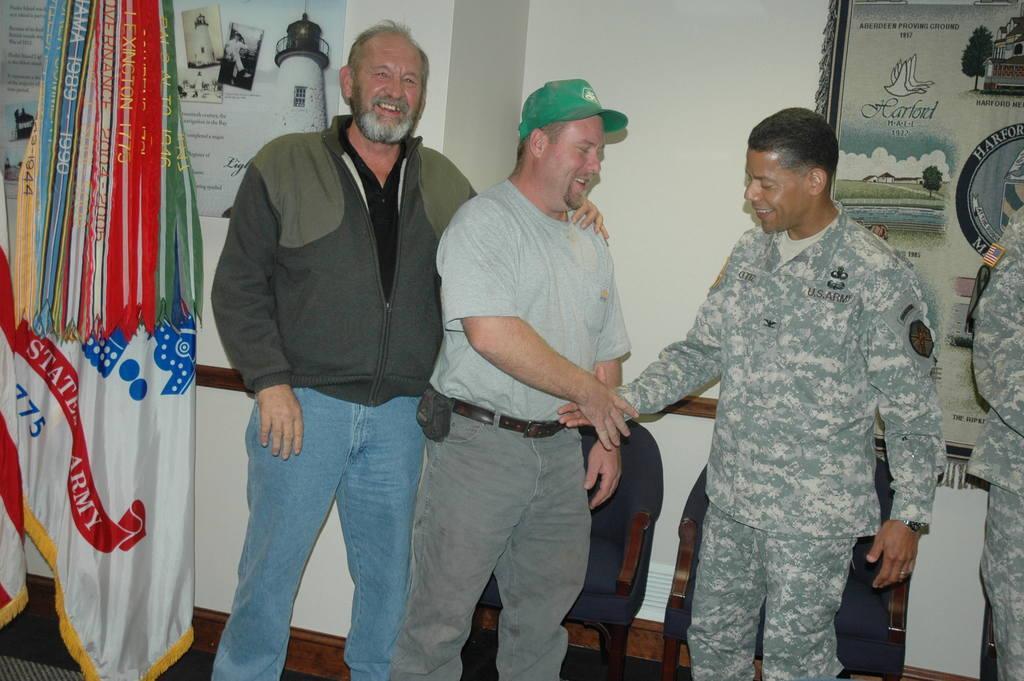How would you summarize this image in a sentence or two? In the center of the image group of men standing on the floor. On the left side of the image we can see poster and flag. In the background there are chairs, poster and wall. 